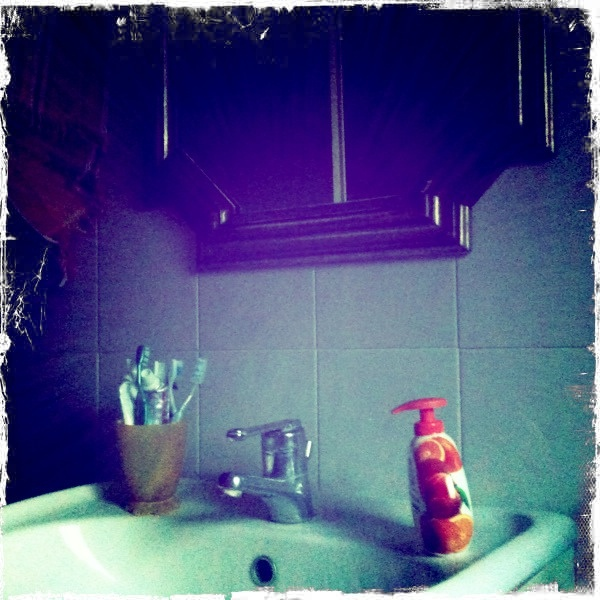Describe the objects in this image and their specific colors. I can see sink in white, beige, teal, aquamarine, and navy tones, bottle in white, purple, navy, and salmon tones, cup in white, gray, navy, and purple tones, toothbrush in white, navy, teal, gray, and blue tones, and toothbrush in white, teal, gray, lightblue, and turquoise tones in this image. 